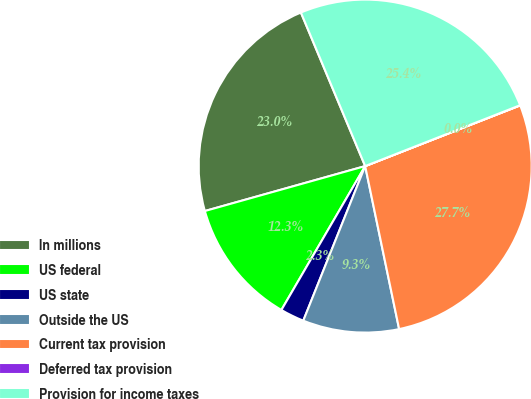Convert chart. <chart><loc_0><loc_0><loc_500><loc_500><pie_chart><fcel>In millions<fcel>US federal<fcel>US state<fcel>Outside the US<fcel>Current tax provision<fcel>Deferred tax provision<fcel>Provision for income taxes<nl><fcel>23.04%<fcel>12.26%<fcel>2.33%<fcel>9.33%<fcel>27.67%<fcel>0.02%<fcel>25.35%<nl></chart> 